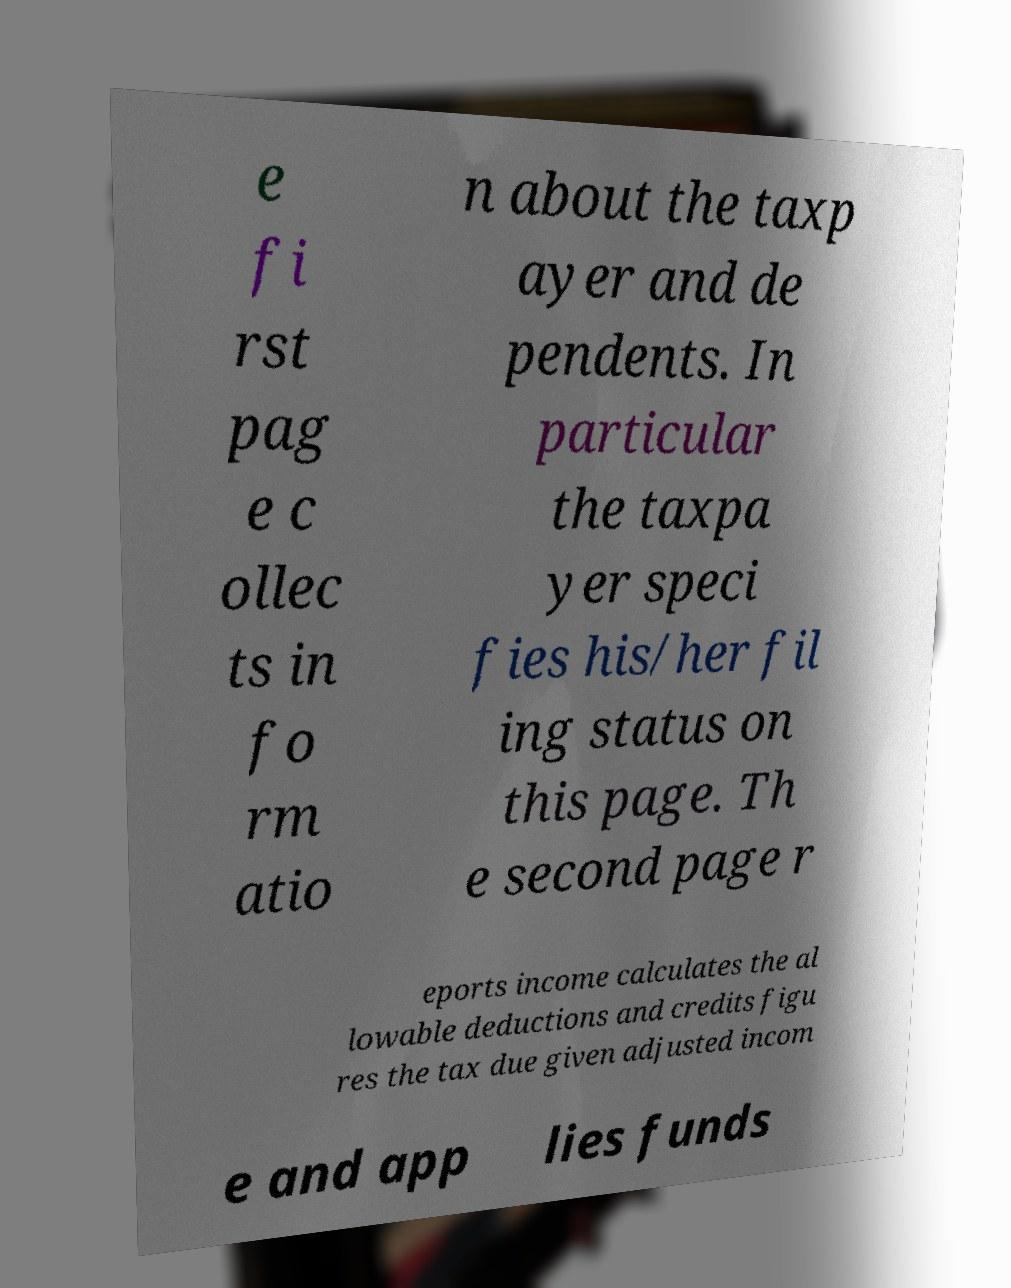Can you read and provide the text displayed in the image?This photo seems to have some interesting text. Can you extract and type it out for me? e fi rst pag e c ollec ts in fo rm atio n about the taxp ayer and de pendents. In particular the taxpa yer speci fies his/her fil ing status on this page. Th e second page r eports income calculates the al lowable deductions and credits figu res the tax due given adjusted incom e and app lies funds 